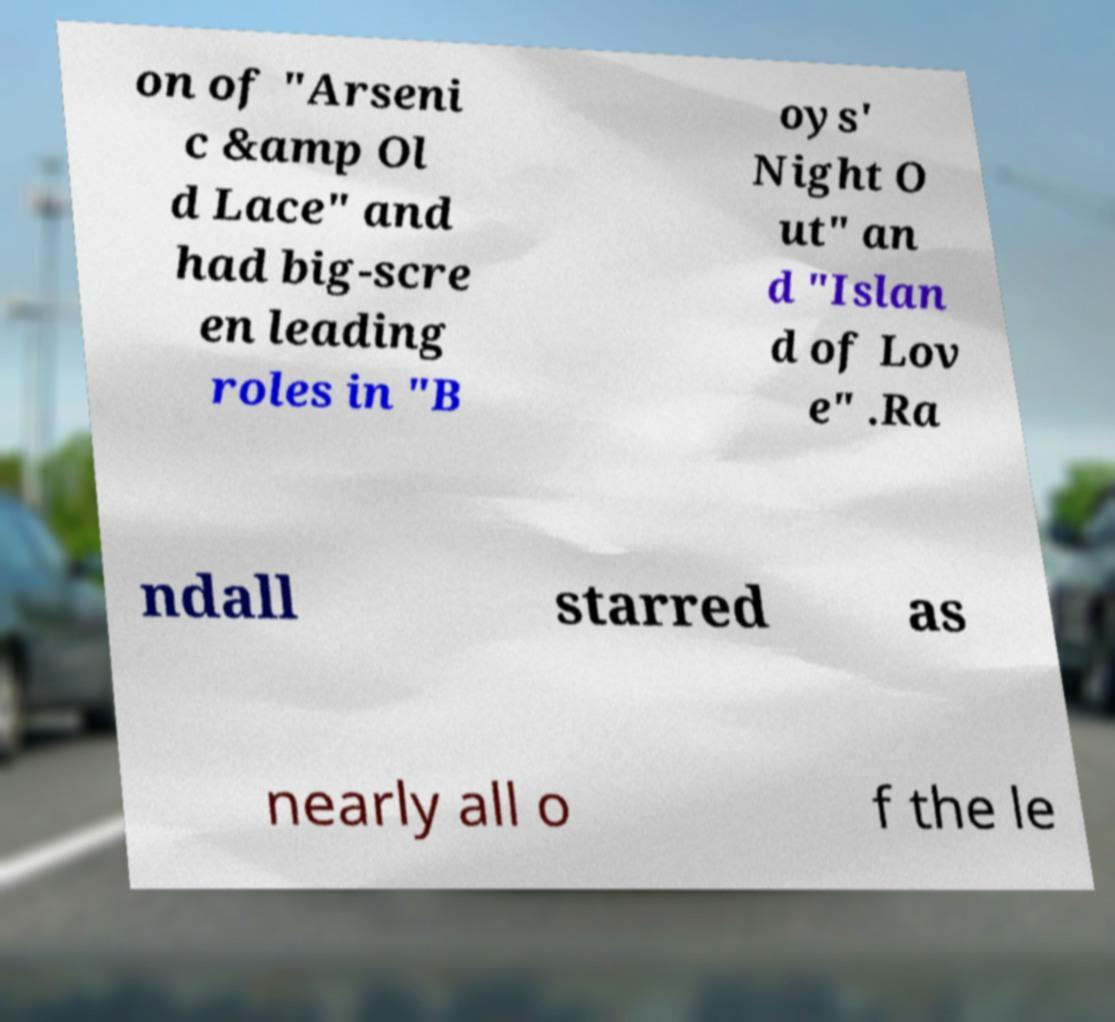Can you accurately transcribe the text from the provided image for me? on of "Arseni c &amp Ol d Lace" and had big-scre en leading roles in "B oys' Night O ut" an d "Islan d of Lov e" .Ra ndall starred as nearly all o f the le 